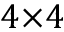<formula> <loc_0><loc_0><loc_500><loc_500>4 { \times } 4</formula> 